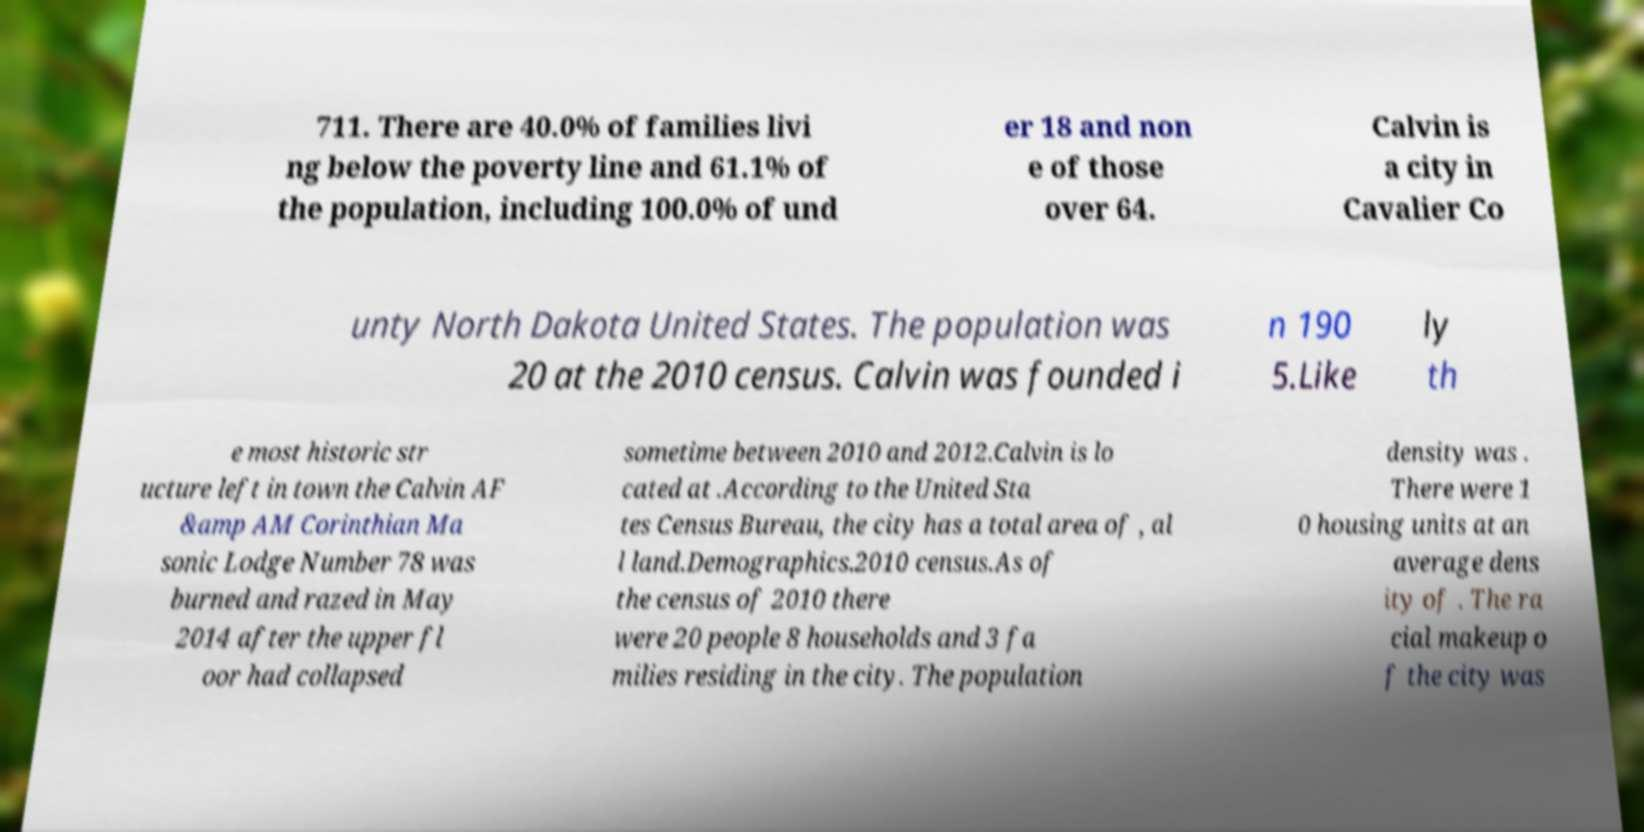Please read and relay the text visible in this image. What does it say? 711. There are 40.0% of families livi ng below the poverty line and 61.1% of the population, including 100.0% of und er 18 and non e of those over 64. Calvin is a city in Cavalier Co unty North Dakota United States. The population was 20 at the 2010 census. Calvin was founded i n 190 5.Like ly th e most historic str ucture left in town the Calvin AF &amp AM Corinthian Ma sonic Lodge Number 78 was burned and razed in May 2014 after the upper fl oor had collapsed sometime between 2010 and 2012.Calvin is lo cated at .According to the United Sta tes Census Bureau, the city has a total area of , al l land.Demographics.2010 census.As of the census of 2010 there were 20 people 8 households and 3 fa milies residing in the city. The population density was . There were 1 0 housing units at an average dens ity of . The ra cial makeup o f the city was 